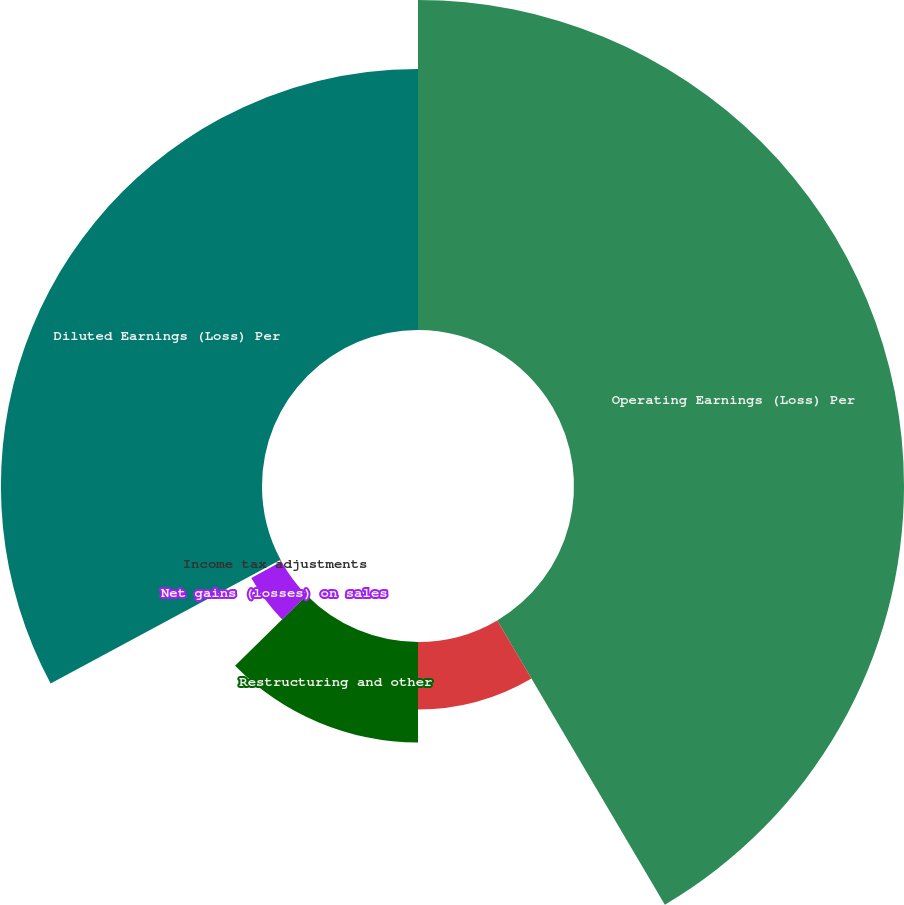Convert chart. <chart><loc_0><loc_0><loc_500><loc_500><pie_chart><fcel>Operating Earnings (Loss) Per<fcel>Non-operating pension expense<fcel>Restructuring and other<fcel>Net gains (losses) on sales<fcel>Income tax adjustments<fcel>Diluted Earnings (Loss) Per<nl><fcel>41.52%<fcel>8.48%<fcel>12.64%<fcel>4.33%<fcel>0.18%<fcel>32.85%<nl></chart> 